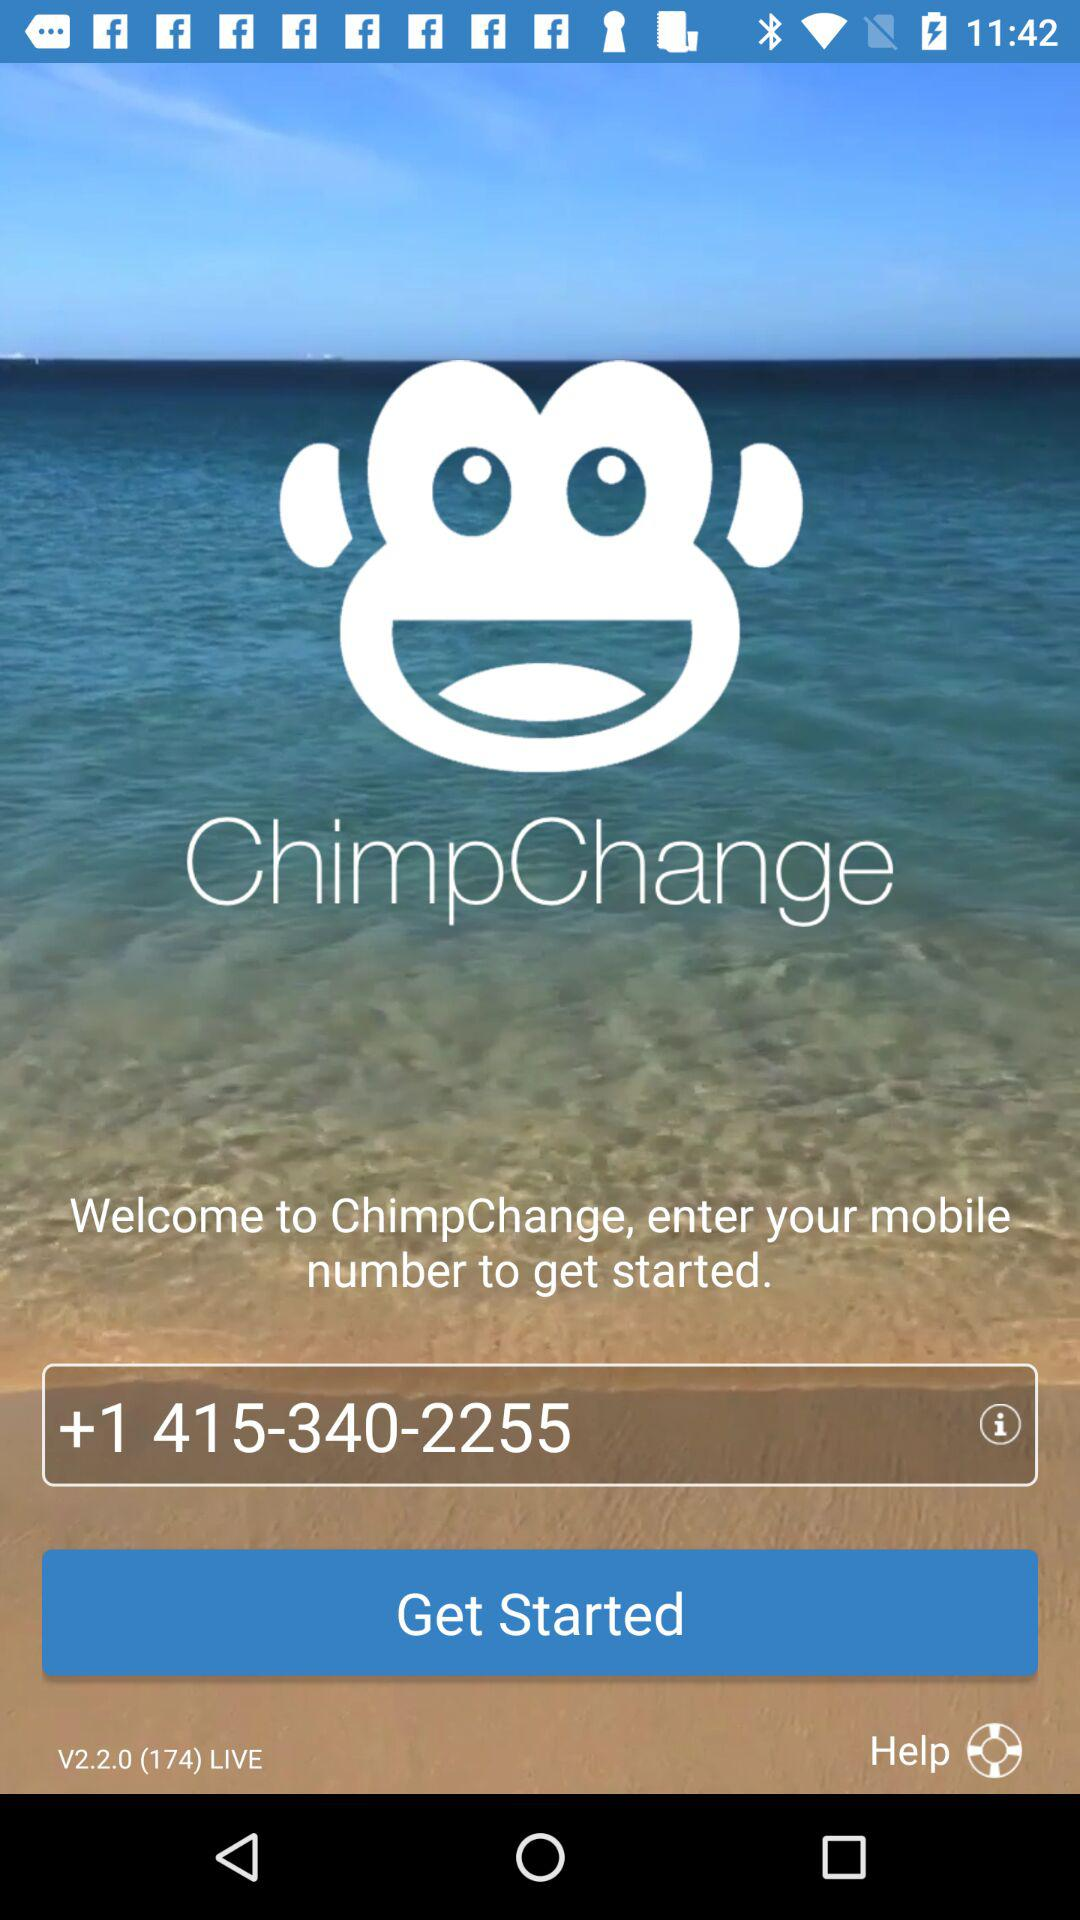What is the phone number?
Answer the question using a single word or phrase. The phone number is +1 415-340-2255 